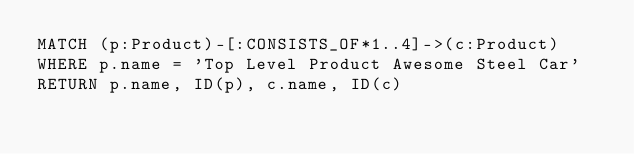Convert code to text. <code><loc_0><loc_0><loc_500><loc_500><_SQL_>MATCH (p:Product)-[:CONSISTS_OF*1..4]->(c:Product)
WHERE p.name = 'Top Level Product Awesome Steel Car'
RETURN p.name, ID(p), c.name, ID(c)</code> 